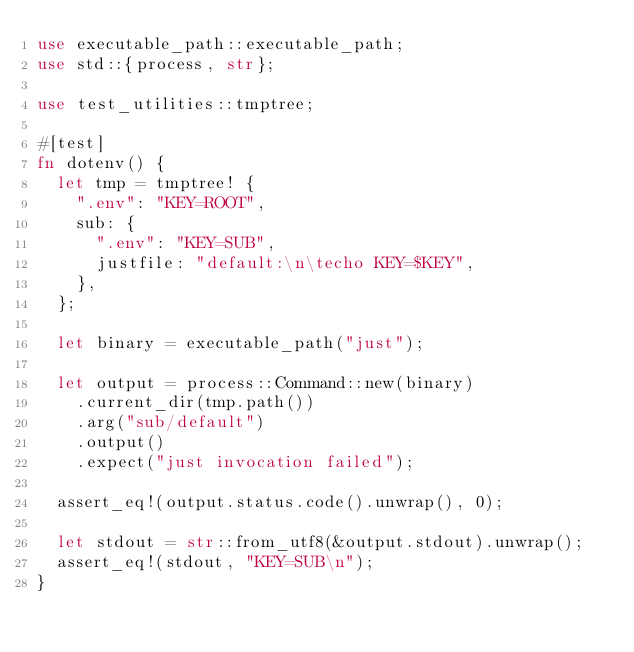Convert code to text. <code><loc_0><loc_0><loc_500><loc_500><_Rust_>use executable_path::executable_path;
use std::{process, str};

use test_utilities::tmptree;

#[test]
fn dotenv() {
  let tmp = tmptree! {
    ".env": "KEY=ROOT",
    sub: {
      ".env": "KEY=SUB",
      justfile: "default:\n\techo KEY=$KEY",
    },
  };

  let binary = executable_path("just");

  let output = process::Command::new(binary)
    .current_dir(tmp.path())
    .arg("sub/default")
    .output()
    .expect("just invocation failed");

  assert_eq!(output.status.code().unwrap(), 0);

  let stdout = str::from_utf8(&output.stdout).unwrap();
  assert_eq!(stdout, "KEY=SUB\n");
}
</code> 